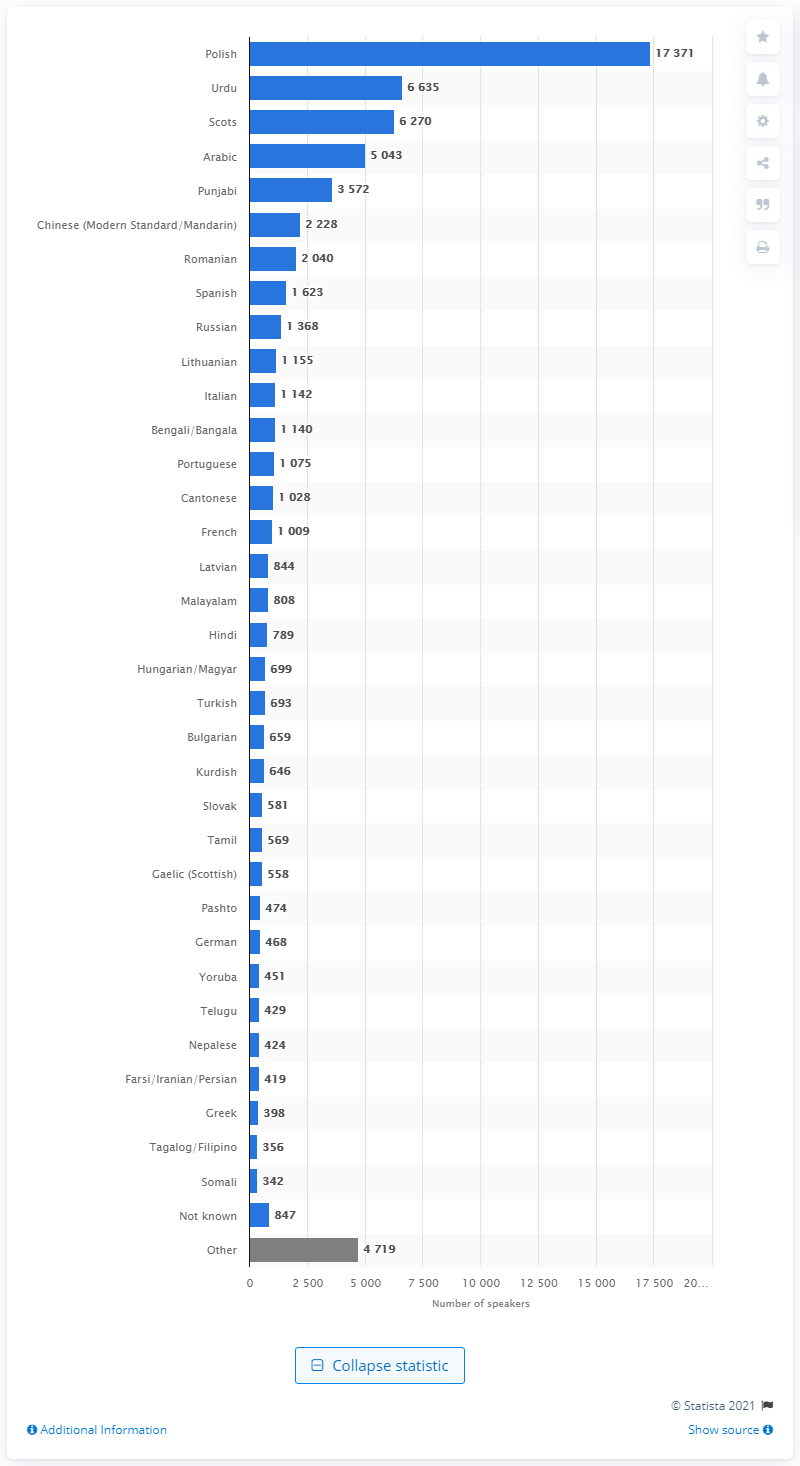Highlight a few significant elements in this photo. The language spoken by 17,370 students in Scotland in 2020 was Polish. In 2020, there were 6,270 students in Scotland who spoke Scots as their main language. It is reported that 6,630 students in Scotland spoke Urdu in 2020. 